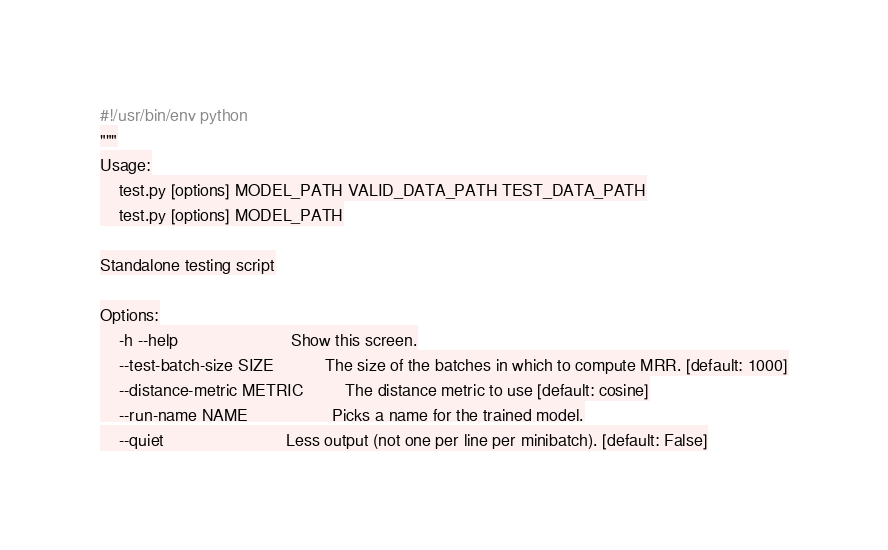Convert code to text. <code><loc_0><loc_0><loc_500><loc_500><_Python_>#!/usr/bin/env python
"""
Usage:
    test.py [options] MODEL_PATH VALID_DATA_PATH TEST_DATA_PATH
    test.py [options] MODEL_PATH

Standalone testing script

Options:
    -h --help                        Show this screen.
    --test-batch-size SIZE           The size of the batches in which to compute MRR. [default: 1000]
    --distance-metric METRIC         The distance metric to use [default: cosine]
    --run-name NAME                  Picks a name for the trained model.
    --quiet                          Less output (not one per line per minibatch). [default: False]</code> 